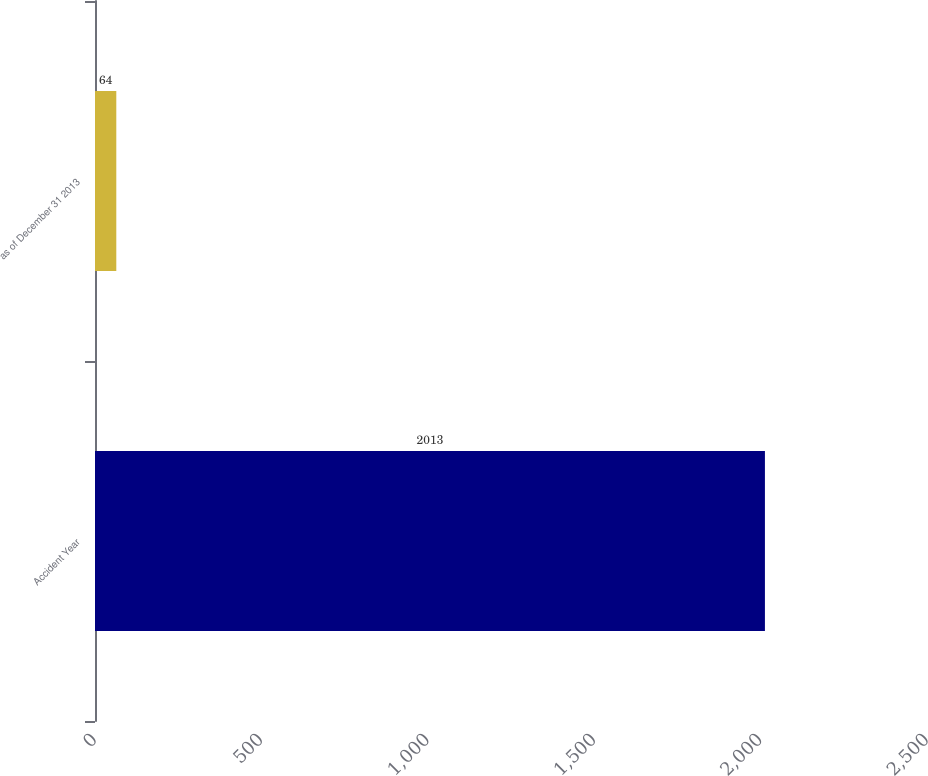Convert chart. <chart><loc_0><loc_0><loc_500><loc_500><bar_chart><fcel>Accident Year<fcel>as of December 31 2013<nl><fcel>2013<fcel>64<nl></chart> 